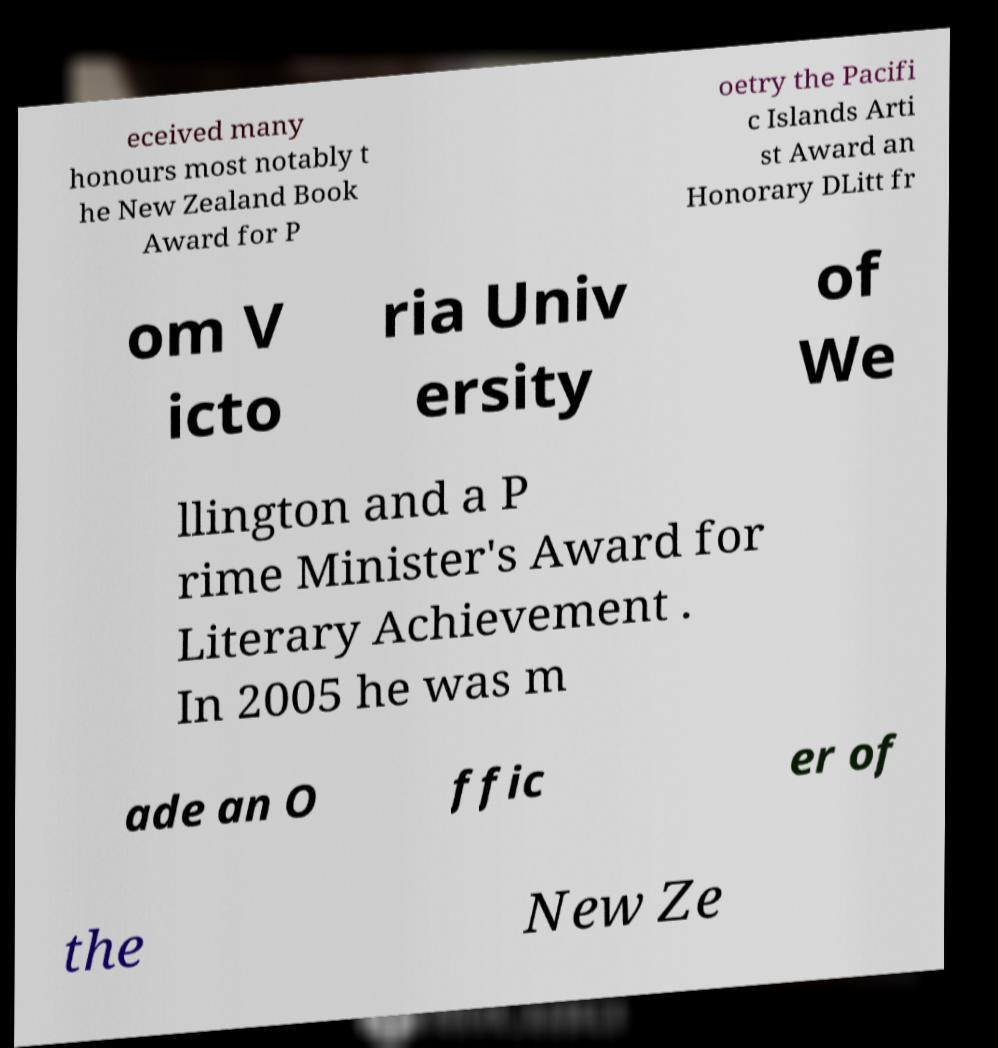Can you accurately transcribe the text from the provided image for me? eceived many honours most notably t he New Zealand Book Award for P oetry the Pacifi c Islands Arti st Award an Honorary DLitt fr om V icto ria Univ ersity of We llington and a P rime Minister's Award for Literary Achievement . In 2005 he was m ade an O ffic er of the New Ze 